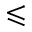Convert formula to latex. <formula><loc_0><loc_0><loc_500><loc_500>\leqslant</formula> 